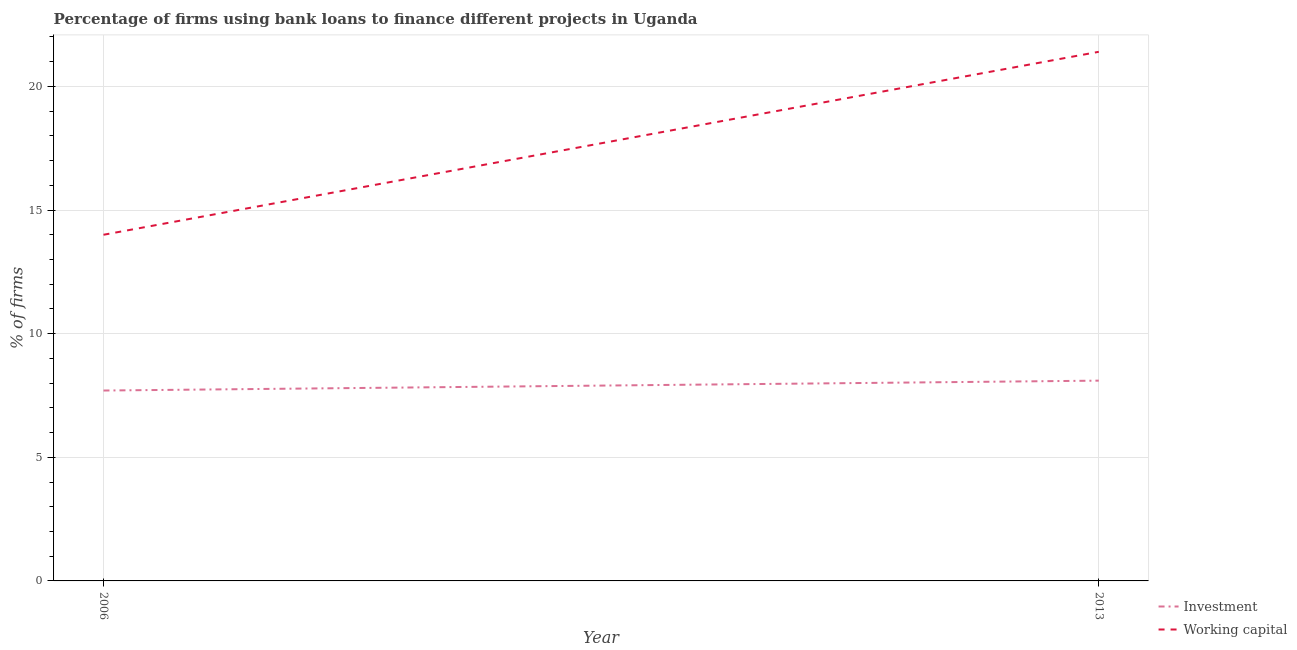How many different coloured lines are there?
Your answer should be very brief. 2. What is the percentage of firms using banks to finance investment in 2013?
Your answer should be compact. 8.1. Across all years, what is the maximum percentage of firms using banks to finance working capital?
Ensure brevity in your answer.  21.4. What is the total percentage of firms using banks to finance investment in the graph?
Provide a short and direct response. 15.8. What is the difference between the percentage of firms using banks to finance working capital in 2006 and that in 2013?
Give a very brief answer. -7.4. What is the difference between the percentage of firms using banks to finance working capital in 2006 and the percentage of firms using banks to finance investment in 2013?
Keep it short and to the point. 5.9. In the year 2013, what is the difference between the percentage of firms using banks to finance working capital and percentage of firms using banks to finance investment?
Offer a terse response. 13.3. In how many years, is the percentage of firms using banks to finance investment greater than 18 %?
Give a very brief answer. 0. What is the ratio of the percentage of firms using banks to finance working capital in 2006 to that in 2013?
Your answer should be very brief. 0.65. Does the percentage of firms using banks to finance working capital monotonically increase over the years?
Your answer should be very brief. Yes. Is the percentage of firms using banks to finance investment strictly greater than the percentage of firms using banks to finance working capital over the years?
Provide a succinct answer. No. How many lines are there?
Provide a succinct answer. 2. Are the values on the major ticks of Y-axis written in scientific E-notation?
Your answer should be very brief. No. Does the graph contain any zero values?
Offer a terse response. No. How many legend labels are there?
Offer a very short reply. 2. How are the legend labels stacked?
Ensure brevity in your answer.  Vertical. What is the title of the graph?
Offer a very short reply. Percentage of firms using bank loans to finance different projects in Uganda. What is the label or title of the X-axis?
Provide a short and direct response. Year. What is the label or title of the Y-axis?
Your answer should be very brief. % of firms. What is the % of firms in Working capital in 2013?
Offer a terse response. 21.4. Across all years, what is the maximum % of firms of Investment?
Your response must be concise. 8.1. Across all years, what is the maximum % of firms of Working capital?
Make the answer very short. 21.4. Across all years, what is the minimum % of firms of Investment?
Provide a short and direct response. 7.7. What is the total % of firms in Investment in the graph?
Offer a terse response. 15.8. What is the total % of firms in Working capital in the graph?
Ensure brevity in your answer.  35.4. What is the difference between the % of firms of Working capital in 2006 and that in 2013?
Offer a terse response. -7.4. What is the difference between the % of firms in Investment in 2006 and the % of firms in Working capital in 2013?
Provide a short and direct response. -13.7. What is the average % of firms in Working capital per year?
Ensure brevity in your answer.  17.7. In the year 2013, what is the difference between the % of firms in Investment and % of firms in Working capital?
Your response must be concise. -13.3. What is the ratio of the % of firms of Investment in 2006 to that in 2013?
Your answer should be compact. 0.95. What is the ratio of the % of firms of Working capital in 2006 to that in 2013?
Offer a very short reply. 0.65. What is the difference between the highest and the second highest % of firms of Working capital?
Your answer should be very brief. 7.4. What is the difference between the highest and the lowest % of firms of Investment?
Ensure brevity in your answer.  0.4. 